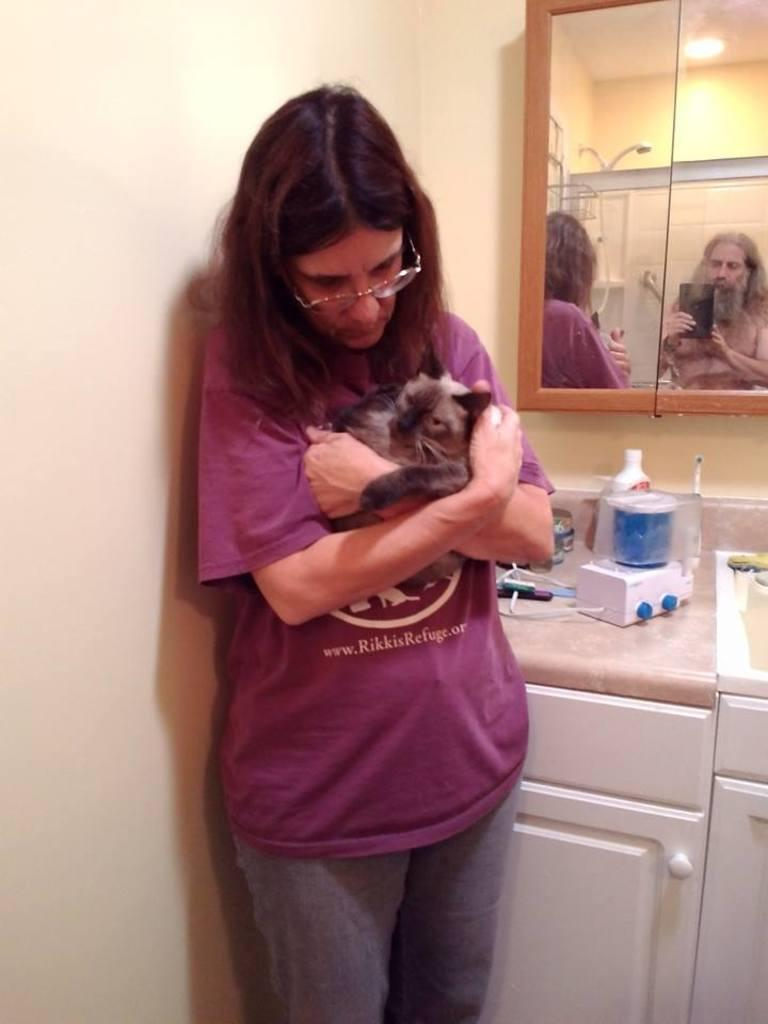What is the main subject of the image? There is a woman in the image. What is the woman doing in the image? The woman is standing and holding a cat in her hands. What can be seen in the background of the image? There is a mirror and a wall in the image. What else is present in the image besides the woman and the cat? There are objects on a table in the image. What is the plot of the story unfolding in the image? There is no story or plot depicted in the image; it is a static scene featuring a woman holding a cat. Is the woman driving a vehicle in the image? No, the woman is not driving a vehicle in the image; she is standing and holding a cat. --- Facts: 1. There is a car in the image. 2. The car is parked on the street. 3. There are trees on both sides of the street. 4. The sky is visible in the image. 5. There is a traffic light in the background. Absurd Topics: parade, elephant, ocean Conversation: What is the main subject of the image? There is a car in the image. Where is the car located in the image? The car is parked on the street. What can be seen on both sides of the street in the image? There are trees on both sides of the street. What is visible in the background of the image? There is a traffic light in the background. What is the condition of the sky in the image? The sky is visible in the image, but no specific condition is mentioned. Reasoning: Let's think step by step in order to produce the conversation. We start by identifying the main subject of the image, which is the car. Then, we describe its location and the presence of trees on both sides of the street. Next, we mention the background element, which is the traffic light. Finally, we acknowledge the presence of the sky but do not make any assumptions about its condition. Absurd Question/Answer: Can you see an elephant marching in the parade in the image? No, there is no parade or elephant present in the image; it features a parked car on the street with trees and a traffic light in the background. 